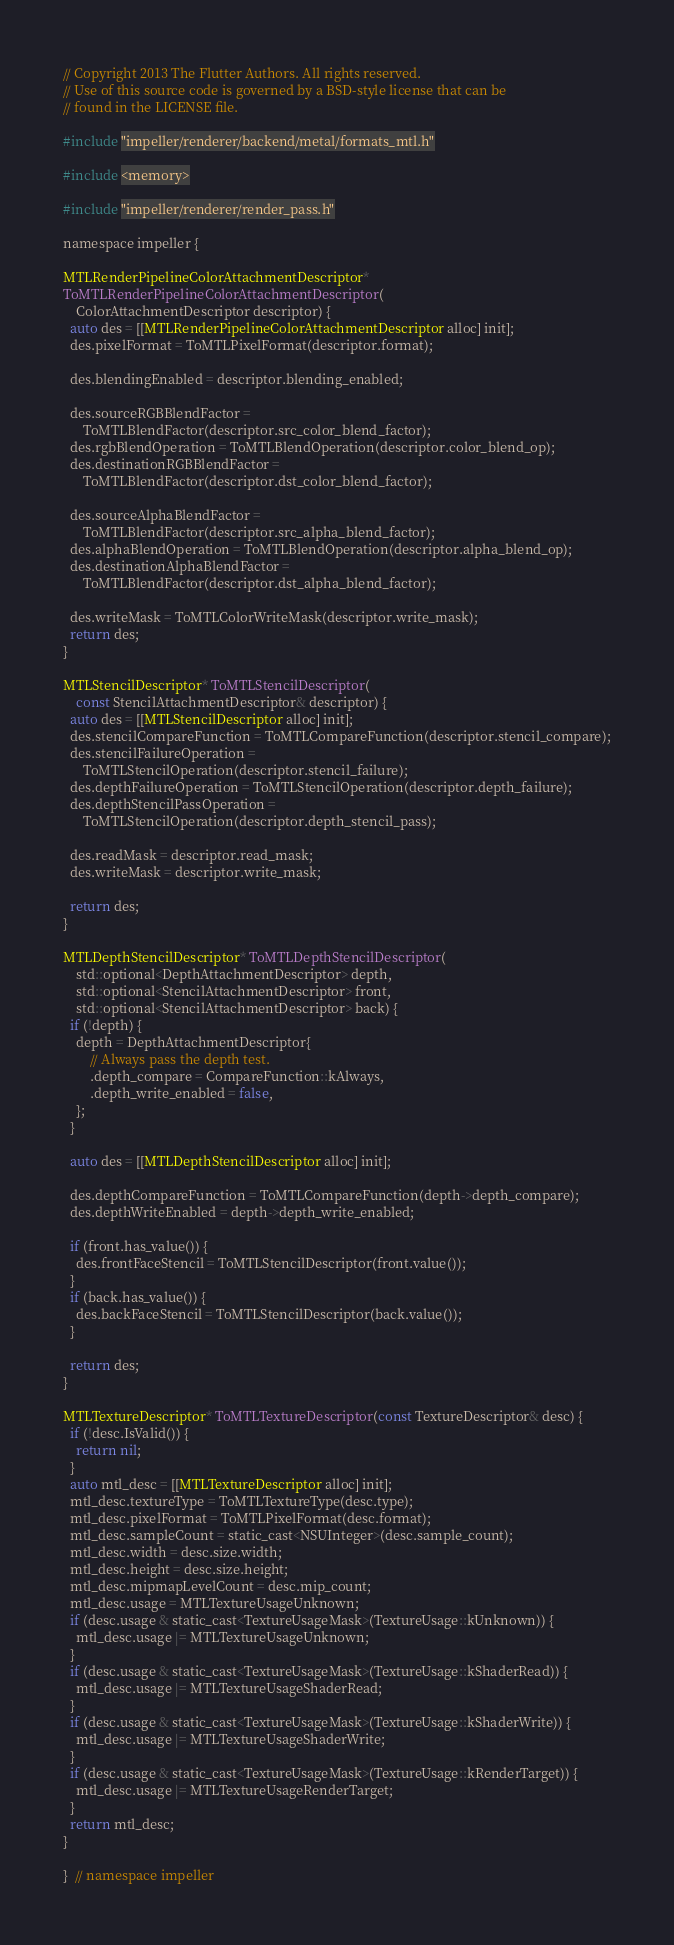Convert code to text. <code><loc_0><loc_0><loc_500><loc_500><_ObjectiveC_>// Copyright 2013 The Flutter Authors. All rights reserved.
// Use of this source code is governed by a BSD-style license that can be
// found in the LICENSE file.

#include "impeller/renderer/backend/metal/formats_mtl.h"

#include <memory>

#include "impeller/renderer/render_pass.h"

namespace impeller {

MTLRenderPipelineColorAttachmentDescriptor*
ToMTLRenderPipelineColorAttachmentDescriptor(
    ColorAttachmentDescriptor descriptor) {
  auto des = [[MTLRenderPipelineColorAttachmentDescriptor alloc] init];
  des.pixelFormat = ToMTLPixelFormat(descriptor.format);

  des.blendingEnabled = descriptor.blending_enabled;

  des.sourceRGBBlendFactor =
      ToMTLBlendFactor(descriptor.src_color_blend_factor);
  des.rgbBlendOperation = ToMTLBlendOperation(descriptor.color_blend_op);
  des.destinationRGBBlendFactor =
      ToMTLBlendFactor(descriptor.dst_color_blend_factor);

  des.sourceAlphaBlendFactor =
      ToMTLBlendFactor(descriptor.src_alpha_blend_factor);
  des.alphaBlendOperation = ToMTLBlendOperation(descriptor.alpha_blend_op);
  des.destinationAlphaBlendFactor =
      ToMTLBlendFactor(descriptor.dst_alpha_blend_factor);

  des.writeMask = ToMTLColorWriteMask(descriptor.write_mask);
  return des;
}

MTLStencilDescriptor* ToMTLStencilDescriptor(
    const StencilAttachmentDescriptor& descriptor) {
  auto des = [[MTLStencilDescriptor alloc] init];
  des.stencilCompareFunction = ToMTLCompareFunction(descriptor.stencil_compare);
  des.stencilFailureOperation =
      ToMTLStencilOperation(descriptor.stencil_failure);
  des.depthFailureOperation = ToMTLStencilOperation(descriptor.depth_failure);
  des.depthStencilPassOperation =
      ToMTLStencilOperation(descriptor.depth_stencil_pass);

  des.readMask = descriptor.read_mask;
  des.writeMask = descriptor.write_mask;

  return des;
}

MTLDepthStencilDescriptor* ToMTLDepthStencilDescriptor(
    std::optional<DepthAttachmentDescriptor> depth,
    std::optional<StencilAttachmentDescriptor> front,
    std::optional<StencilAttachmentDescriptor> back) {
  if (!depth) {
    depth = DepthAttachmentDescriptor{
        // Always pass the depth test.
        .depth_compare = CompareFunction::kAlways,
        .depth_write_enabled = false,
    };
  }

  auto des = [[MTLDepthStencilDescriptor alloc] init];

  des.depthCompareFunction = ToMTLCompareFunction(depth->depth_compare);
  des.depthWriteEnabled = depth->depth_write_enabled;

  if (front.has_value()) {
    des.frontFaceStencil = ToMTLStencilDescriptor(front.value());
  }
  if (back.has_value()) {
    des.backFaceStencil = ToMTLStencilDescriptor(back.value());
  }

  return des;
}

MTLTextureDescriptor* ToMTLTextureDescriptor(const TextureDescriptor& desc) {
  if (!desc.IsValid()) {
    return nil;
  }
  auto mtl_desc = [[MTLTextureDescriptor alloc] init];
  mtl_desc.textureType = ToMTLTextureType(desc.type);
  mtl_desc.pixelFormat = ToMTLPixelFormat(desc.format);
  mtl_desc.sampleCount = static_cast<NSUInteger>(desc.sample_count);
  mtl_desc.width = desc.size.width;
  mtl_desc.height = desc.size.height;
  mtl_desc.mipmapLevelCount = desc.mip_count;
  mtl_desc.usage = MTLTextureUsageUnknown;
  if (desc.usage & static_cast<TextureUsageMask>(TextureUsage::kUnknown)) {
    mtl_desc.usage |= MTLTextureUsageUnknown;
  }
  if (desc.usage & static_cast<TextureUsageMask>(TextureUsage::kShaderRead)) {
    mtl_desc.usage |= MTLTextureUsageShaderRead;
  }
  if (desc.usage & static_cast<TextureUsageMask>(TextureUsage::kShaderWrite)) {
    mtl_desc.usage |= MTLTextureUsageShaderWrite;
  }
  if (desc.usage & static_cast<TextureUsageMask>(TextureUsage::kRenderTarget)) {
    mtl_desc.usage |= MTLTextureUsageRenderTarget;
  }
  return mtl_desc;
}

}  // namespace impeller
</code> 